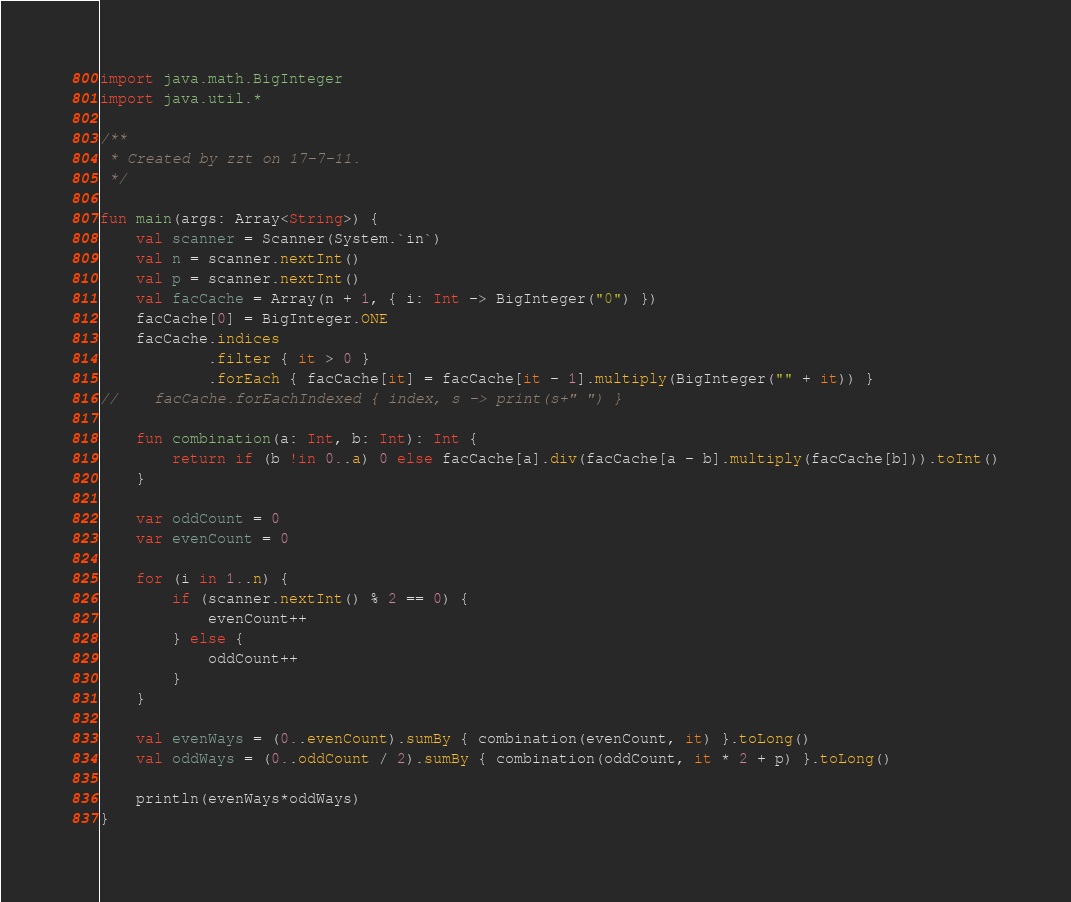<code> <loc_0><loc_0><loc_500><loc_500><_Kotlin_>import java.math.BigInteger
import java.util.*

/**
 * Created by zzt on 17-7-11.
 */

fun main(args: Array<String>) {
    val scanner = Scanner(System.`in`)
    val n = scanner.nextInt()
    val p = scanner.nextInt()
    val facCache = Array(n + 1, { i: Int -> BigInteger("0") })
    facCache[0] = BigInteger.ONE
    facCache.indices
            .filter { it > 0 }
            .forEach { facCache[it] = facCache[it - 1].multiply(BigInteger("" + it)) }
//    facCache.forEachIndexed { index, s -> print(s+" ") }

    fun combination(a: Int, b: Int): Int {
        return if (b !in 0..a) 0 else facCache[a].div(facCache[a - b].multiply(facCache[b])).toInt()
    }

    var oddCount = 0
    var evenCount = 0

    for (i in 1..n) {
        if (scanner.nextInt() % 2 == 0) {
            evenCount++
        } else {
            oddCount++
        }
    }

    val evenWays = (0..evenCount).sumBy { combination(evenCount, it) }.toLong()
    val oddWays = (0..oddCount / 2).sumBy { combination(oddCount, it * 2 + p) }.toLong()

    println(evenWays*oddWays)
}</code> 